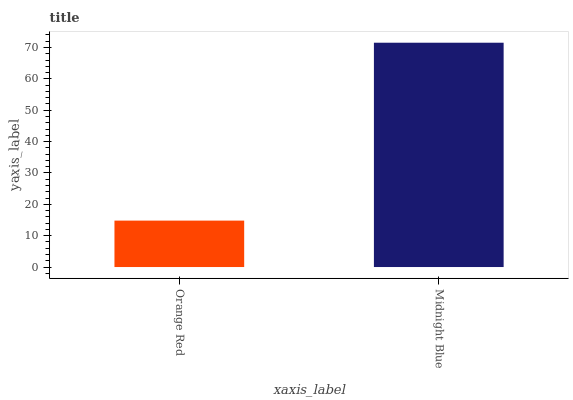Is Midnight Blue the minimum?
Answer yes or no. No. Is Midnight Blue greater than Orange Red?
Answer yes or no. Yes. Is Orange Red less than Midnight Blue?
Answer yes or no. Yes. Is Orange Red greater than Midnight Blue?
Answer yes or no. No. Is Midnight Blue less than Orange Red?
Answer yes or no. No. Is Midnight Blue the high median?
Answer yes or no. Yes. Is Orange Red the low median?
Answer yes or no. Yes. Is Orange Red the high median?
Answer yes or no. No. Is Midnight Blue the low median?
Answer yes or no. No. 